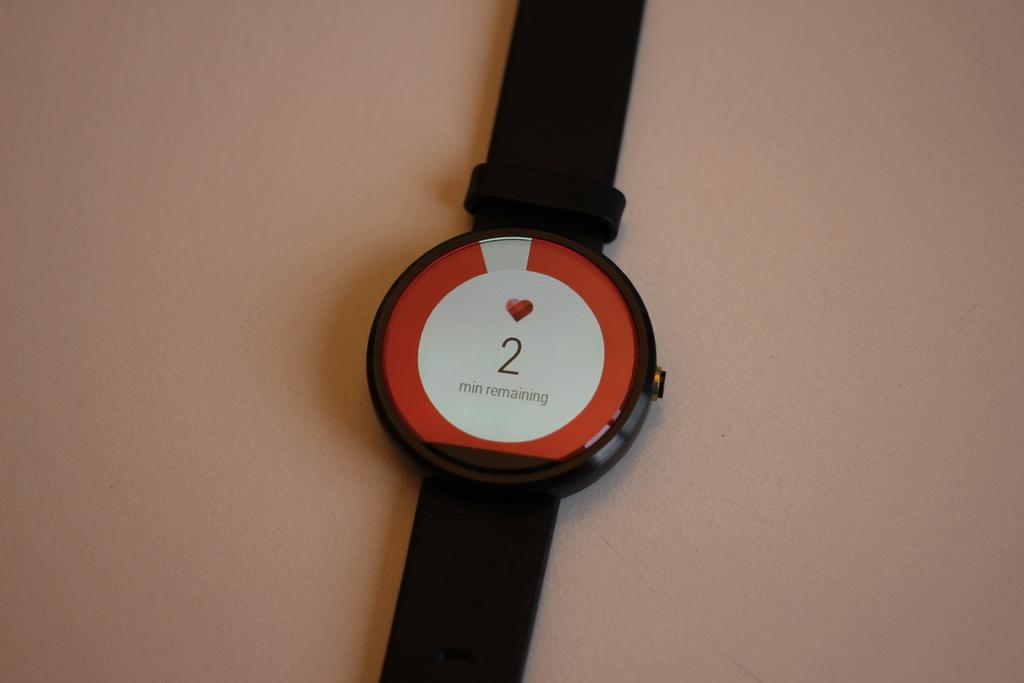<image>
Provide a brief description of the given image. A watch says that there are two minutes remaining and shows a heart. 